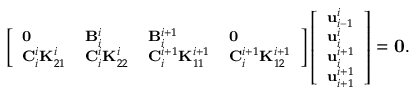<formula> <loc_0><loc_0><loc_500><loc_500>\left [ \begin{array} { l l l l } { 0 } & { B _ { i } ^ { i } } & { B _ { i } ^ { i + 1 } } & { 0 } \\ { C _ { i } ^ { i } K _ { 2 1 } ^ { i } } & { C _ { i } ^ { i } K _ { 2 2 } ^ { i } } & { C _ { i } ^ { i + 1 } K _ { 1 1 } ^ { i + 1 } } & { C _ { i } ^ { i + 1 } K _ { 1 2 } ^ { i + 1 } } \end{array} \right ] \left [ \begin{array} { l } { u _ { i - 1 } ^ { i } } \\ { u _ { i } ^ { i } } \\ { u _ { i } ^ { i + 1 } } \\ { u _ { i + 1 } ^ { i + 1 } } \end{array} \right ] = 0 .</formula> 